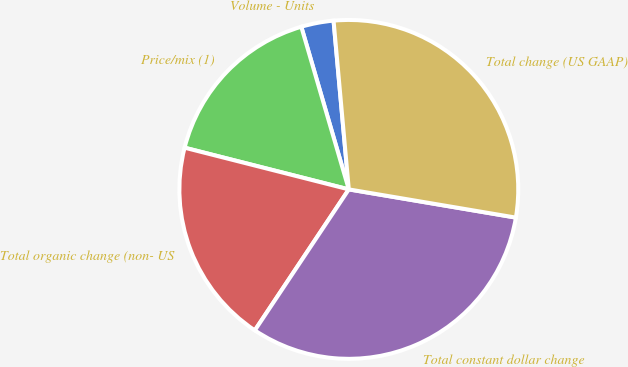<chart> <loc_0><loc_0><loc_500><loc_500><pie_chart><fcel>Volume - Units<fcel>Price/mix (1)<fcel>Total organic change (non- US<fcel>Total constant dollar change<fcel>Total change (US GAAP)<nl><fcel>3.09%<fcel>16.52%<fcel>19.6%<fcel>31.7%<fcel>29.1%<nl></chart> 